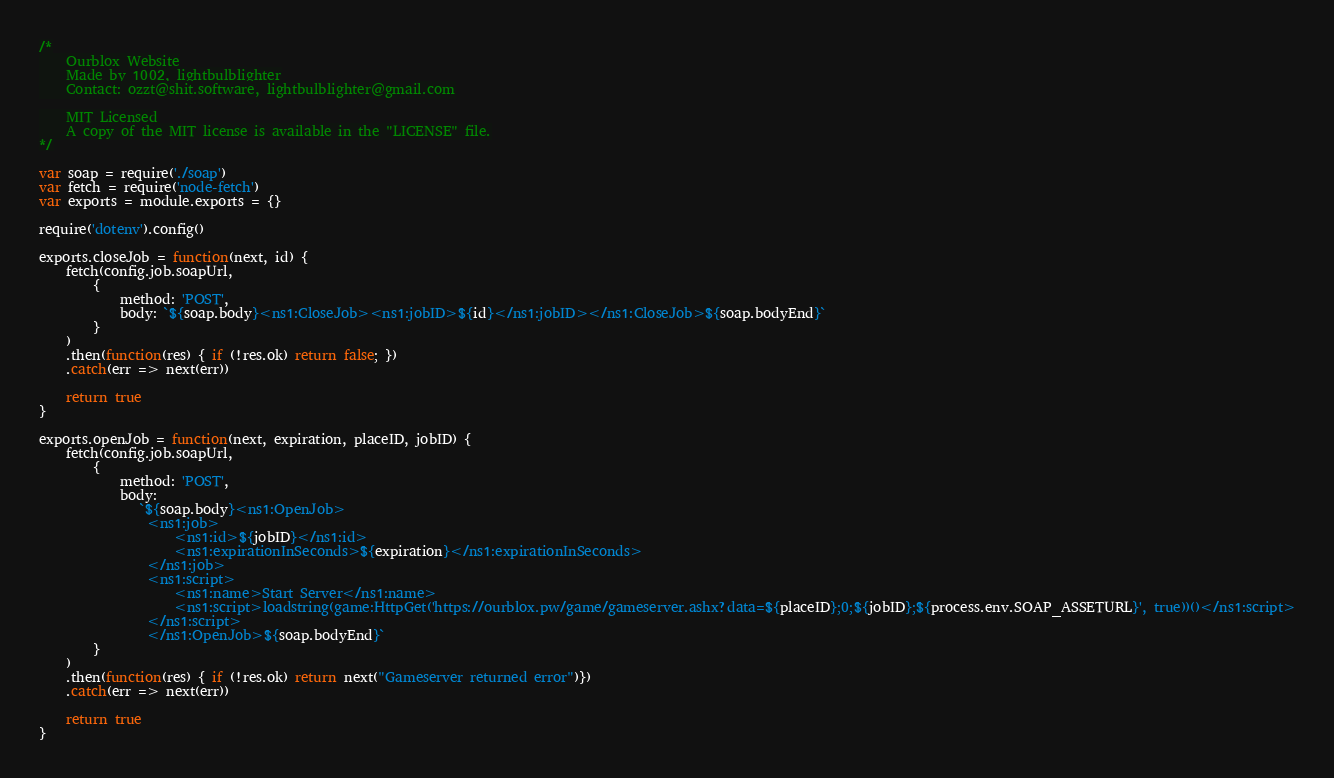Convert code to text. <code><loc_0><loc_0><loc_500><loc_500><_JavaScript_>/*
    Ourblox Website
    Made by 1002, lightbulblighter
    Contact: ozzt@shit.software, lightbulblighter@gmail.com

    MIT Licensed
	A copy of the MIT license is available in the "LICENSE" file.
*/

var soap = require('./soap')
var fetch = require('node-fetch')
var exports = module.exports = {}

require('dotenv').config()

exports.closeJob = function(next, id) {
    fetch(config.job.soapUrl, 
        {
            method: 'POST', 
            body: `${soap.body}<ns1:CloseJob><ns1:jobID>${id}</ns1:jobID></ns1:CloseJob>${soap.bodyEnd}` 
        }
    )
    .then(function(res) { if (!res.ok) return false; })
    .catch(err => next(err))

    return true
}

exports.openJob = function(next, expiration, placeID, jobID) {
    fetch(config.job.soapUrl, 
        {
            method: 'POST', 
            body: 
               `${soap.body}<ns1:OpenJob>
                <ns1:job>
                    <ns1:id>${jobID}</ns1:id>
                    <ns1:expirationInSeconds>${expiration}</ns1:expirationInSeconds>
                </ns1:job>
                <ns1:script>
                    <ns1:name>Start Server</ns1:name>
                    <ns1:script>loadstring(game:HttpGet('https://ourblox.pw/game/gameserver.ashx?data=${placeID};0;${jobID};${process.env.SOAP_ASSETURL}', true))()</ns1:script>
                </ns1:script>
                </ns1:OpenJob>${soap.bodyEnd}` 
        }
    )
    .then(function(res) { if (!res.ok) return next("Gameserver returned error")})
    .catch(err => next(err))

    return true
}</code> 